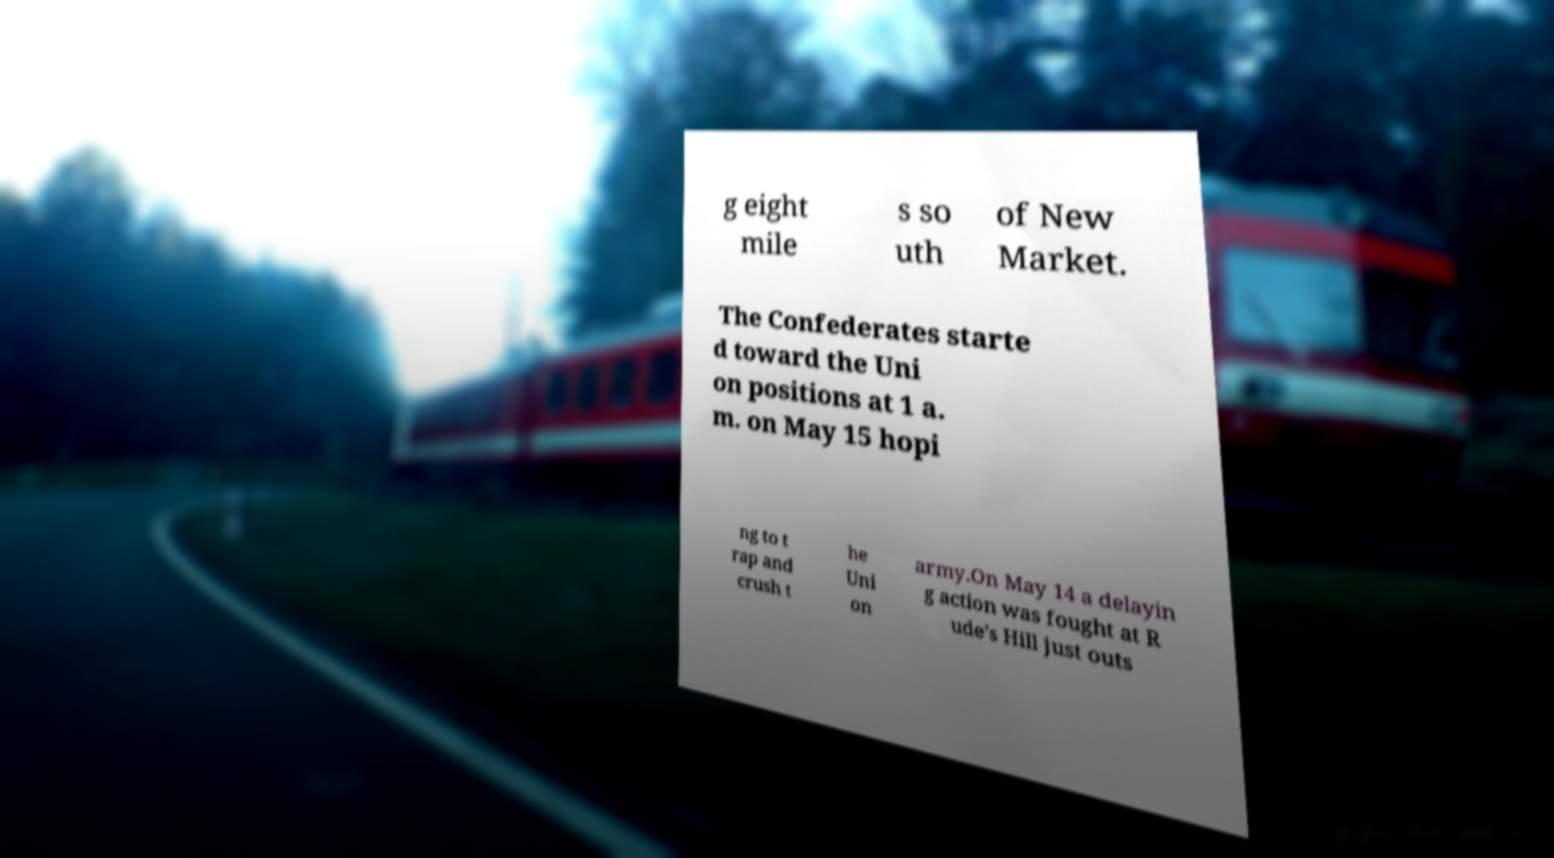Could you assist in decoding the text presented in this image and type it out clearly? g eight mile s so uth of New Market. The Confederates starte d toward the Uni on positions at 1 a. m. on May 15 hopi ng to t rap and crush t he Uni on army.On May 14 a delayin g action was fought at R ude's Hill just outs 